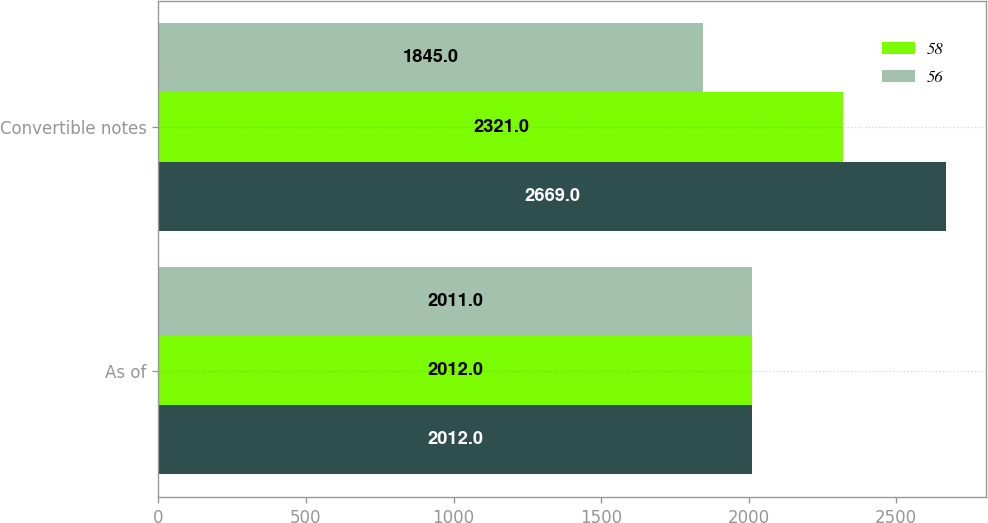<chart> <loc_0><loc_0><loc_500><loc_500><stacked_bar_chart><ecel><fcel>As of<fcel>Convertible notes<nl><fcel>nan<fcel>2012<fcel>2669<nl><fcel>58<fcel>2012<fcel>2321<nl><fcel>56<fcel>2011<fcel>1845<nl></chart> 